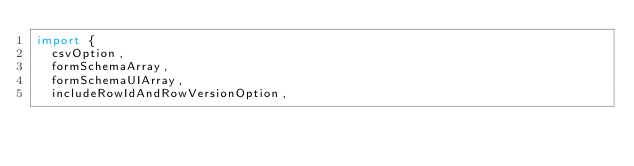<code> <loc_0><loc_0><loc_500><loc_500><_TypeScript_>import {
  csvOption,
  formSchemaArray,
  formSchemaUIArray,
  includeRowIdAndRowVersionOption,</code> 